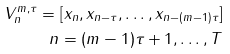Convert formula to latex. <formula><loc_0><loc_0><loc_500><loc_500>V _ { n } ^ { m , \tau } = [ x _ { n } , x _ { n - \tau } , \dots , x _ { n - ( m - 1 ) \tau } ] \\ n = ( m - 1 ) \tau + 1 , \dots , T</formula> 